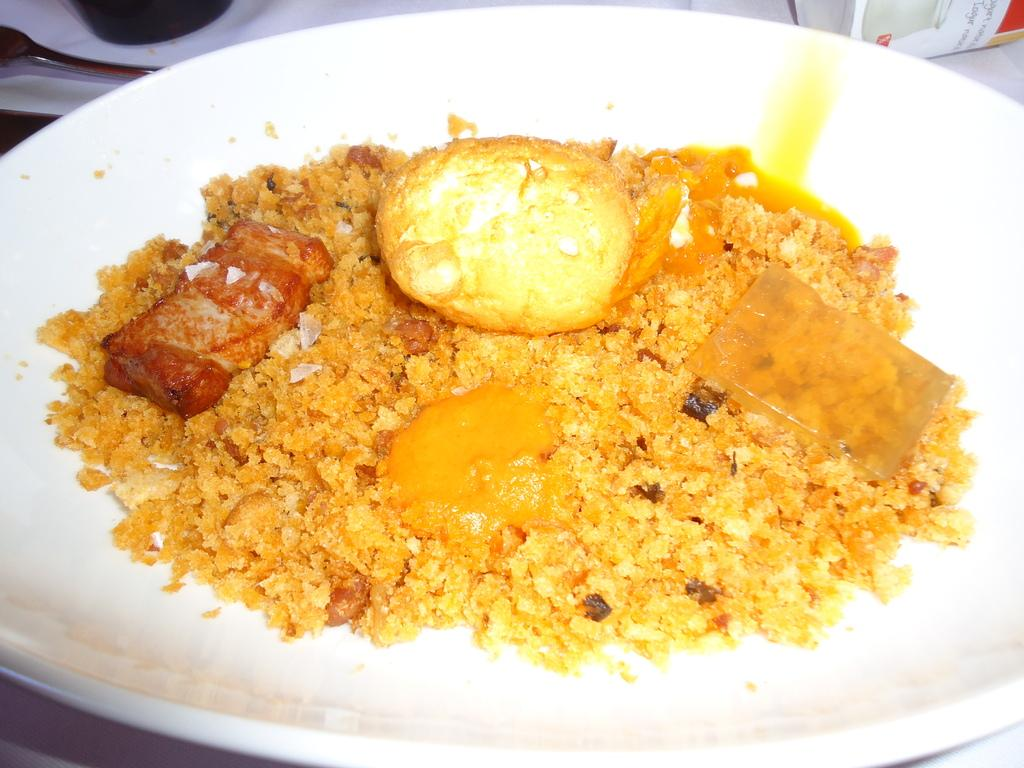What is on the plate that is visible in the image? There is food on a plate in the image. How many plates can be seen on the table in the image? There are plates on the table in the image. What utensil is visible on the table in the image? There is a spoon on the table in the image. What other objects are present on the table in the image? There is a bottle and a box on the table in the image. What type of yam is being served in the house in the image? There is no yam present in the image, and it does not depict a house. 